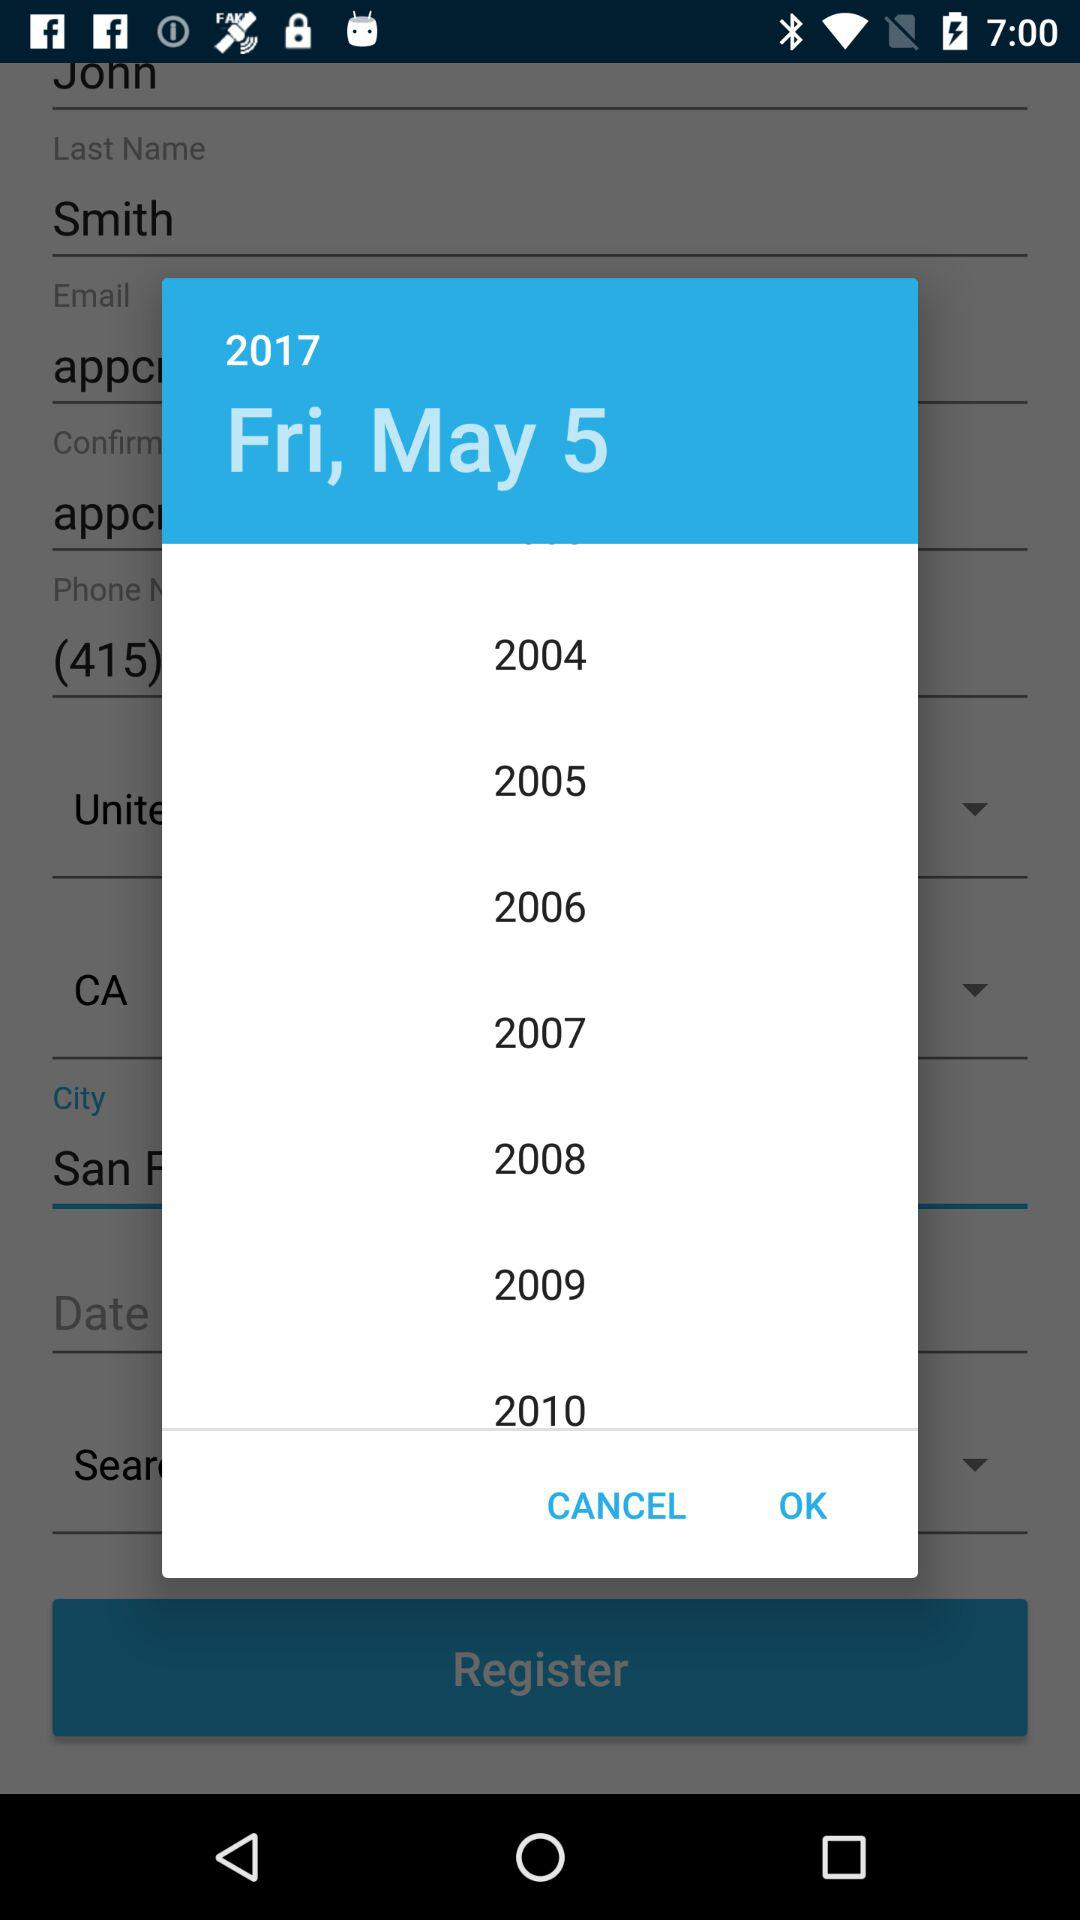What is the selected date? The selected date is Friday, May 5, 2017. 